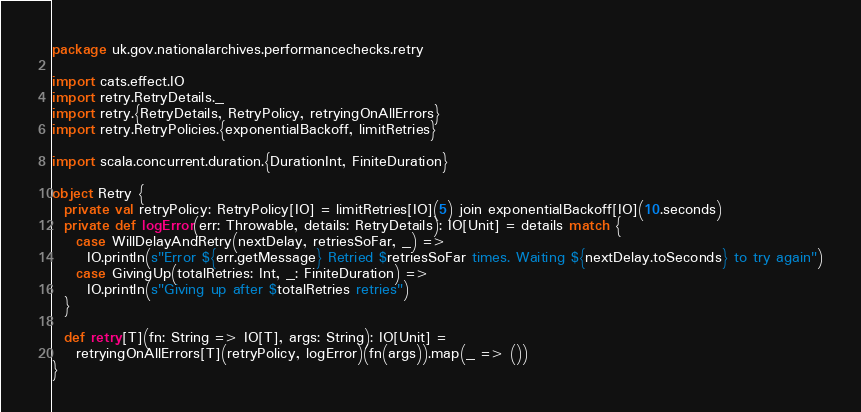Convert code to text. <code><loc_0><loc_0><loc_500><loc_500><_Scala_>package uk.gov.nationalarchives.performancechecks.retry

import cats.effect.IO
import retry.RetryDetails._
import retry.{RetryDetails, RetryPolicy, retryingOnAllErrors}
import retry.RetryPolicies.{exponentialBackoff, limitRetries}

import scala.concurrent.duration.{DurationInt, FiniteDuration}

object Retry {
  private val retryPolicy: RetryPolicy[IO] = limitRetries[IO](5) join exponentialBackoff[IO](10.seconds)
  private def logError(err: Throwable, details: RetryDetails): IO[Unit] = details match {
    case WillDelayAndRetry(nextDelay, retriesSoFar, _) =>
      IO.println(s"Error ${err.getMessage} Retried $retriesSoFar times. Waiting ${nextDelay.toSeconds} to try again")
    case GivingUp(totalRetries: Int, _: FiniteDuration) =>
      IO.println(s"Giving up after $totalRetries retries")
  }

  def retry[T](fn: String => IO[T], args: String): IO[Unit] =
    retryingOnAllErrors[T](retryPolicy, logError)(fn(args)).map(_ => ())
}
</code> 